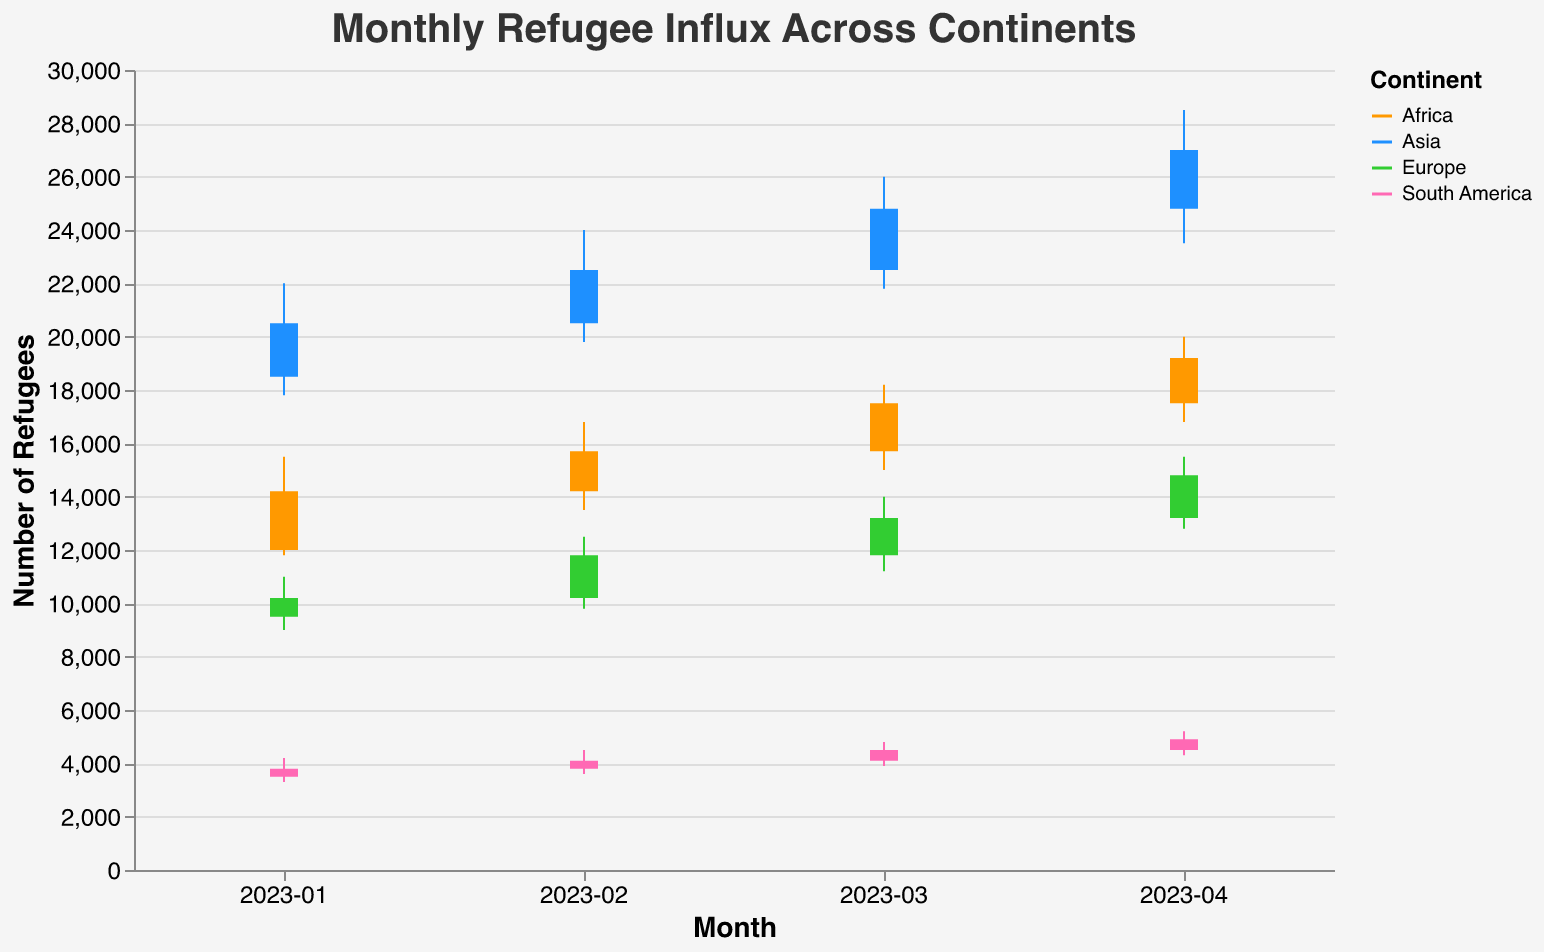What is the title of the chart? The title of the chart is usually found at the top and provides an overview of what the chart is about. In this case, it is "Monthly Refugee Influx Across Continents".
Answer: Monthly Refugee Influx Across Continents Which continent had the highest refugee influx high point in April 2023? To answer this, we look at the "High" values for each continent in April 2023. The highest value is 28500 for Asia.
Answer: Asia What is the range of refugee influx in Africa in January 2023 (from Low to High)? The range is calculated by subtracting the Low value from the High value. For Africa in January 2023, the High is 15500 and the Low is 11800. Therefore, the range is 15500 - 11800 = 3700.
Answer: 3700 Which continent showed the largest increase in refugee influx from January to April 2023 (based on Close values)? To answer this, we look at the Close values for each continent in January and April 2023 and calculate the difference. 
Africa: 19200 - 14200 = 5000
Asia: 27000 - 20500 = 6500
Europe: 14800 - 10200 = 4600
South America: 4900 - 3800 = 1100
Asia had the largest increase of 6500.
Answer: Asia Which two continents had the closest refugee influx values in February 2023? We compare the Close values for each continent in February 2023: Africa (15700), Asia (22500), Europe (11800), and South America (4100). The smallest difference is between Africa and Europe (15700 - 11800 = 3900).
Answer: Africa and Europe What was the opening refugee influx in Europe in March 2023? This can be found directly by looking at the "Open" value for Europe in March 2023, which is 11800.
Answer: 11800 Which month did South America see the highest refugee influx? We need to compare the High values for South America across all months. January (4200), February (4500), March (4800), April (5200). The highest value is 5200 in April.
Answer: April How did the refugee influx in Asia change from February to March 2023? Compare the Open and Close values in February (Open: 20500, Close: 22500) to March (Open: 22500, Close: 24800). This shows an increase from 22500 to 24800.
Answer: Increased What is the average closing refugee influx in Africa for the first four months of 2023? Sum the Close values for Africa in the first four months: 
14200 (Jan), 15700 (Feb), 17500 (Mar), 19200 (Apr). 
The total is 66600. Divide this by 4 to get the average: 66600 / 4 = 16650.
Answer: 16650 Among continents, which one showed a trend of continuous increase in refugee influx every month from January to April 2023 (based on Close values)? Check the Close values for each continent from January to April:
Africa: 14200 (Jan), 15700 (Feb), 17500 (Mar), 19200 (Apr).
Asia: 20500 (Jan), 22500 (Feb), 24800 (Mar), 27000 (Apr).
Europe: 10200 (Jan), 11800 (Feb), 13200 (Mar), 14800 (Apr).
South America: 3800 (Jan), 4100 (Feb), 4500 (Mar), 4900 (Apr).
All continents show a continuous increase each month.
Answer: All continents 